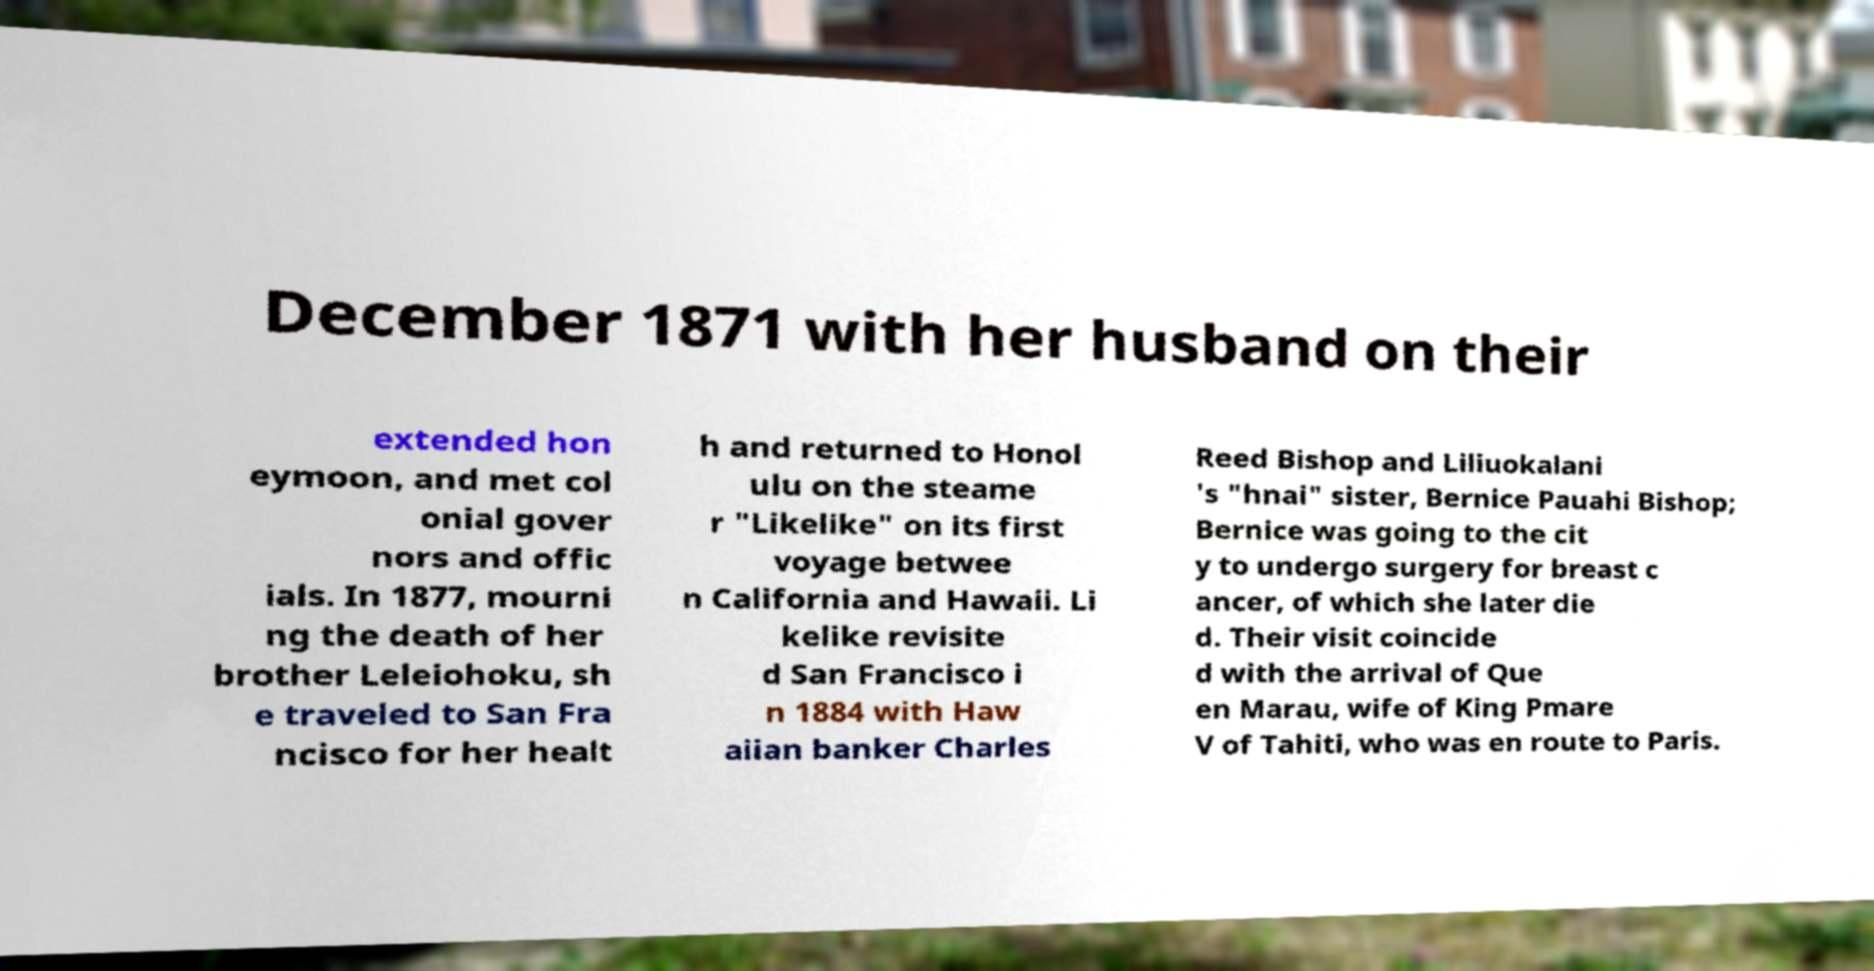There's text embedded in this image that I need extracted. Can you transcribe it verbatim? December 1871 with her husband on their extended hon eymoon, and met col onial gover nors and offic ials. In 1877, mourni ng the death of her brother Leleiohoku, sh e traveled to San Fra ncisco for her healt h and returned to Honol ulu on the steame r "Likelike" on its first voyage betwee n California and Hawaii. Li kelike revisite d San Francisco i n 1884 with Haw aiian banker Charles Reed Bishop and Liliuokalani 's "hnai" sister, Bernice Pauahi Bishop; Bernice was going to the cit y to undergo surgery for breast c ancer, of which she later die d. Their visit coincide d with the arrival of Que en Marau, wife of King Pmare V of Tahiti, who was en route to Paris. 